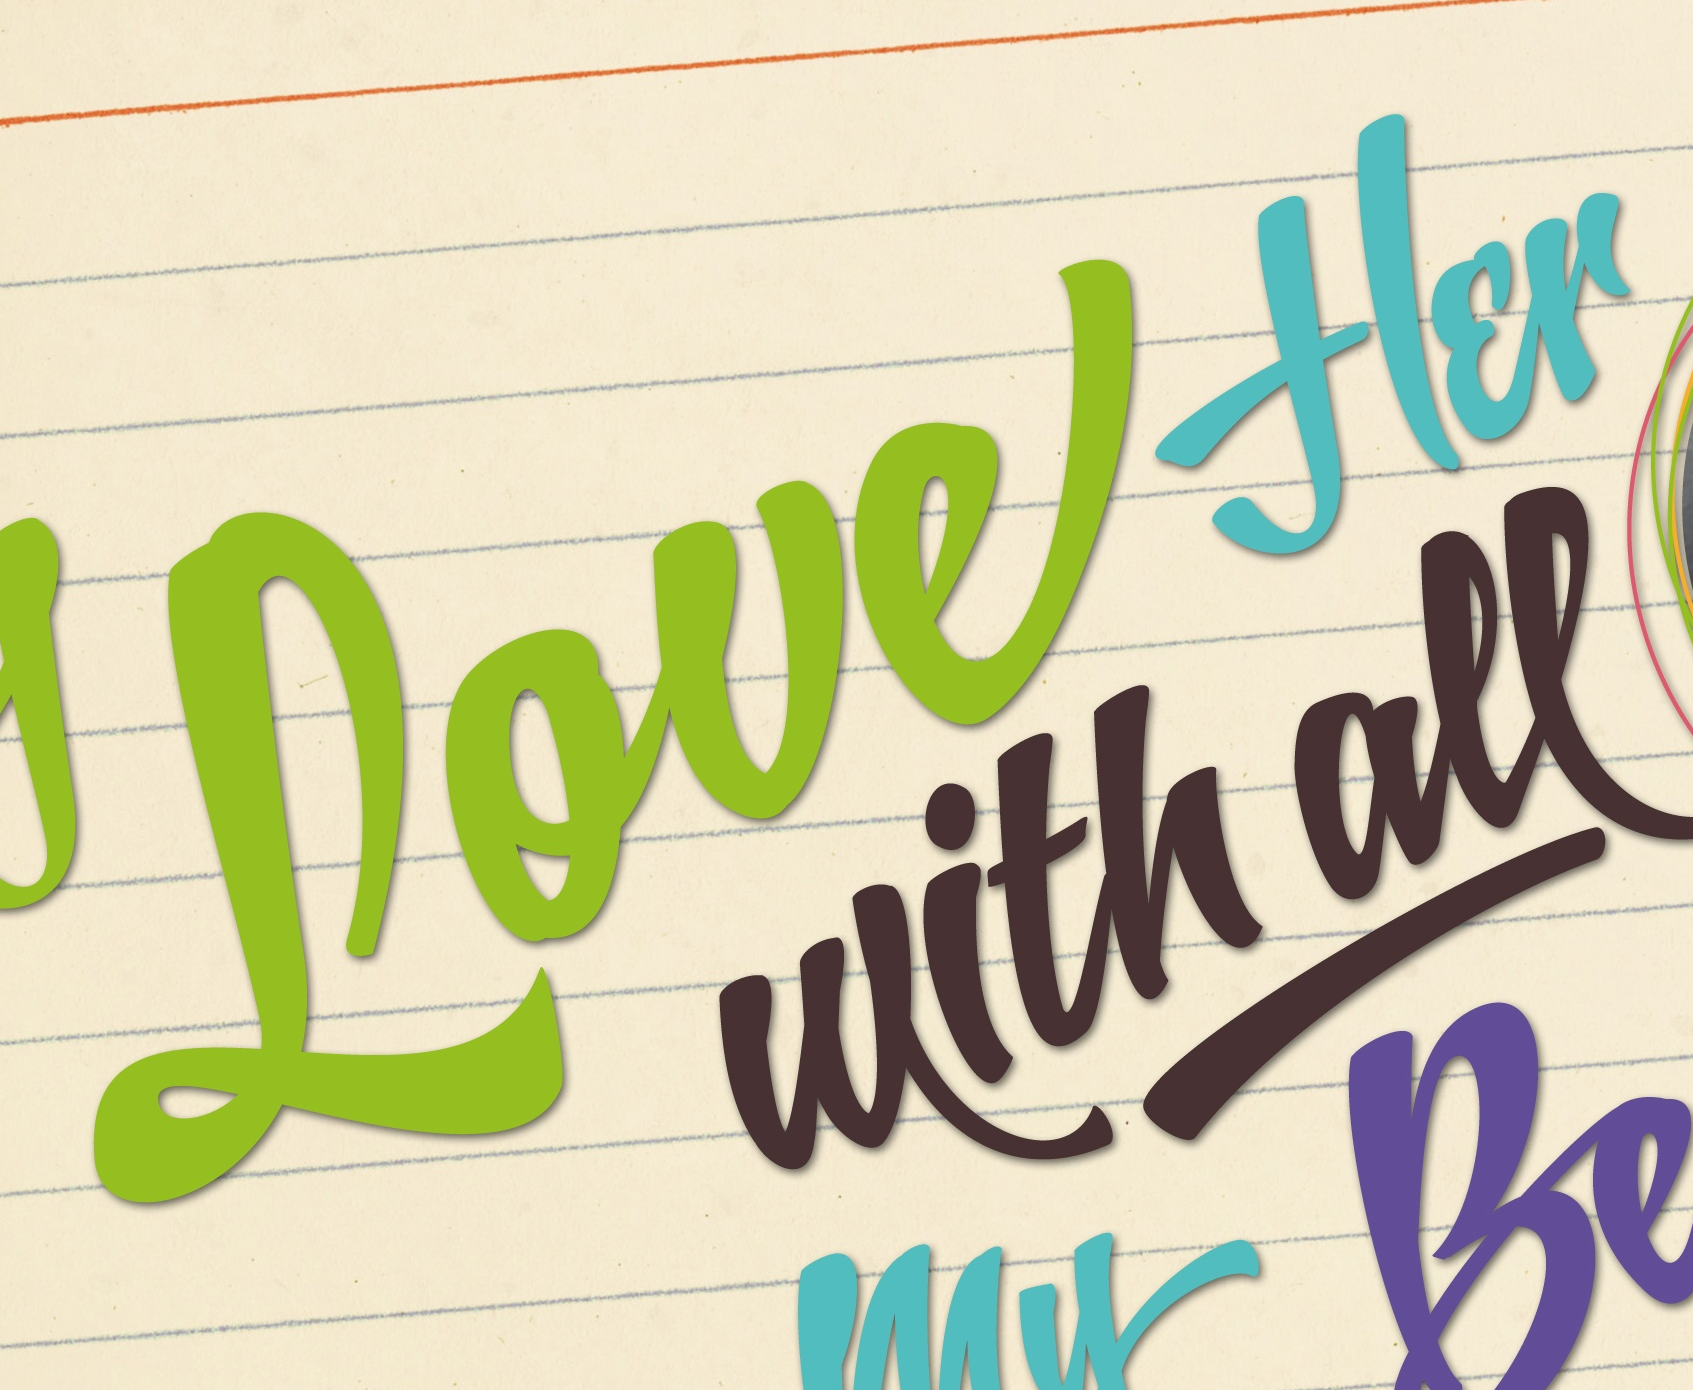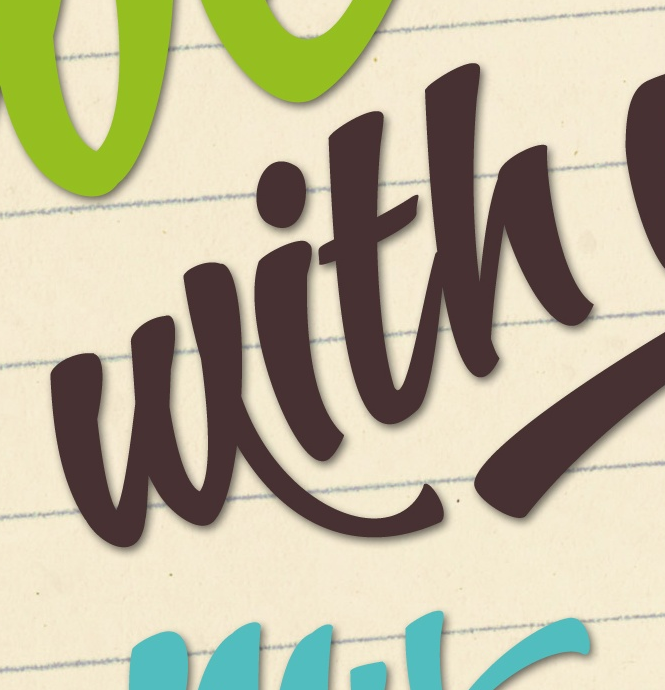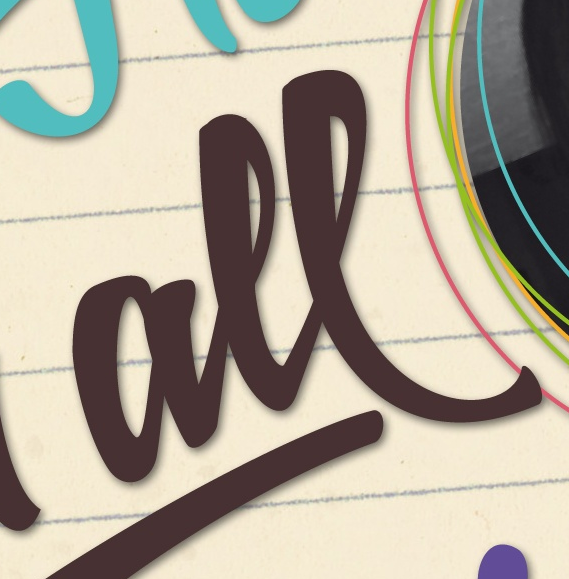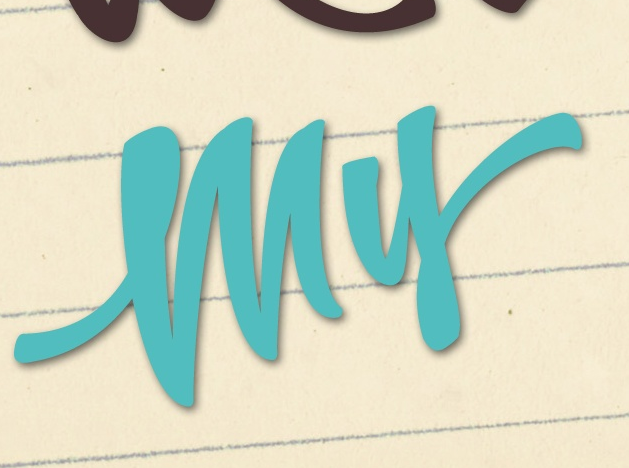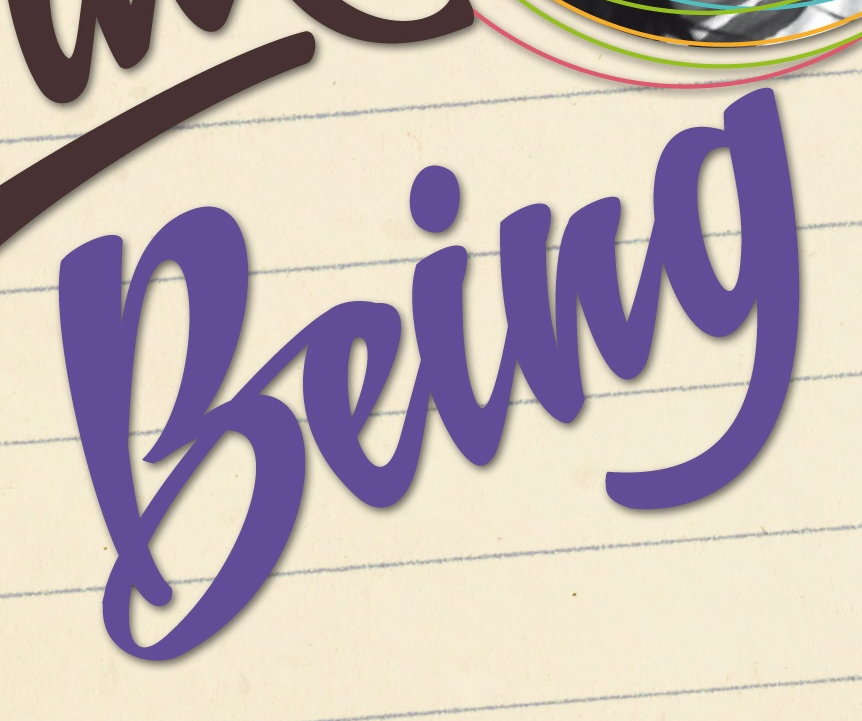What words can you see in these images in sequence, separated by a semicolon? Loueflɛr; with; all; my; being 